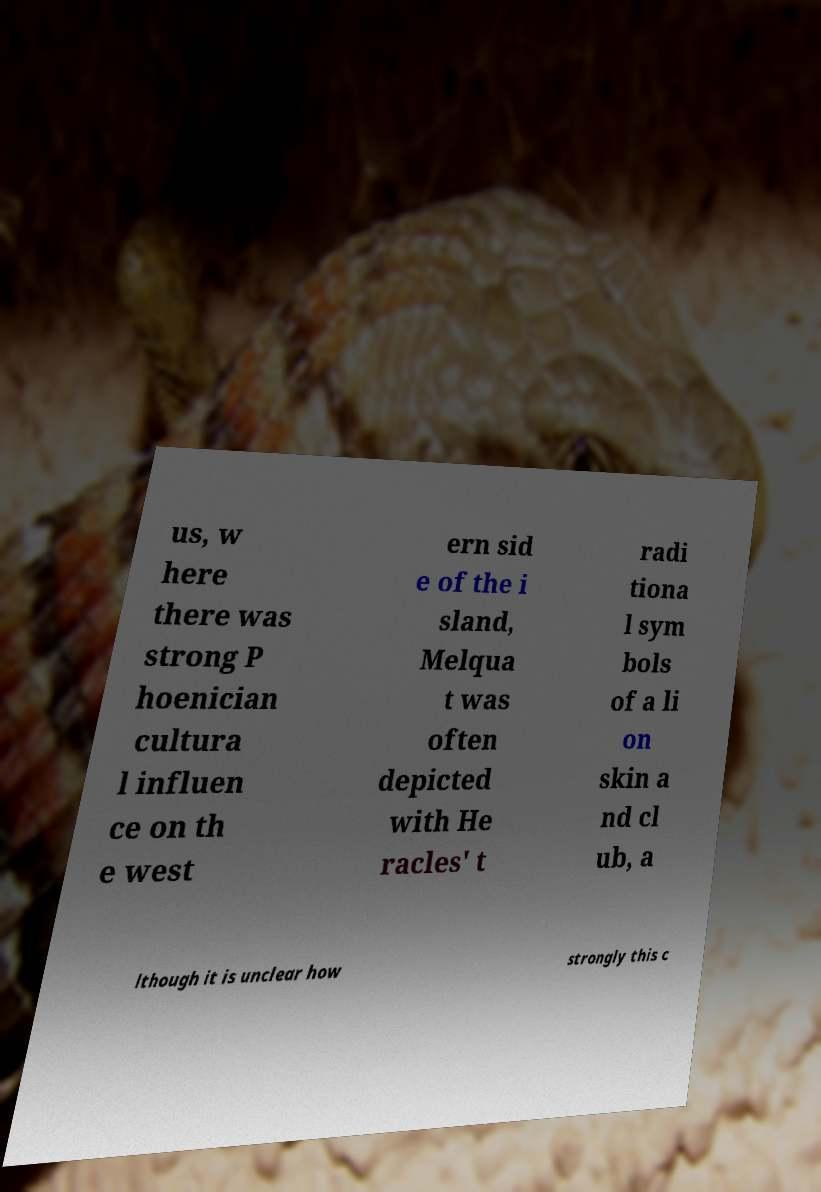Please identify and transcribe the text found in this image. us, w here there was strong P hoenician cultura l influen ce on th e west ern sid e of the i sland, Melqua t was often depicted with He racles' t radi tiona l sym bols of a li on skin a nd cl ub, a lthough it is unclear how strongly this c 